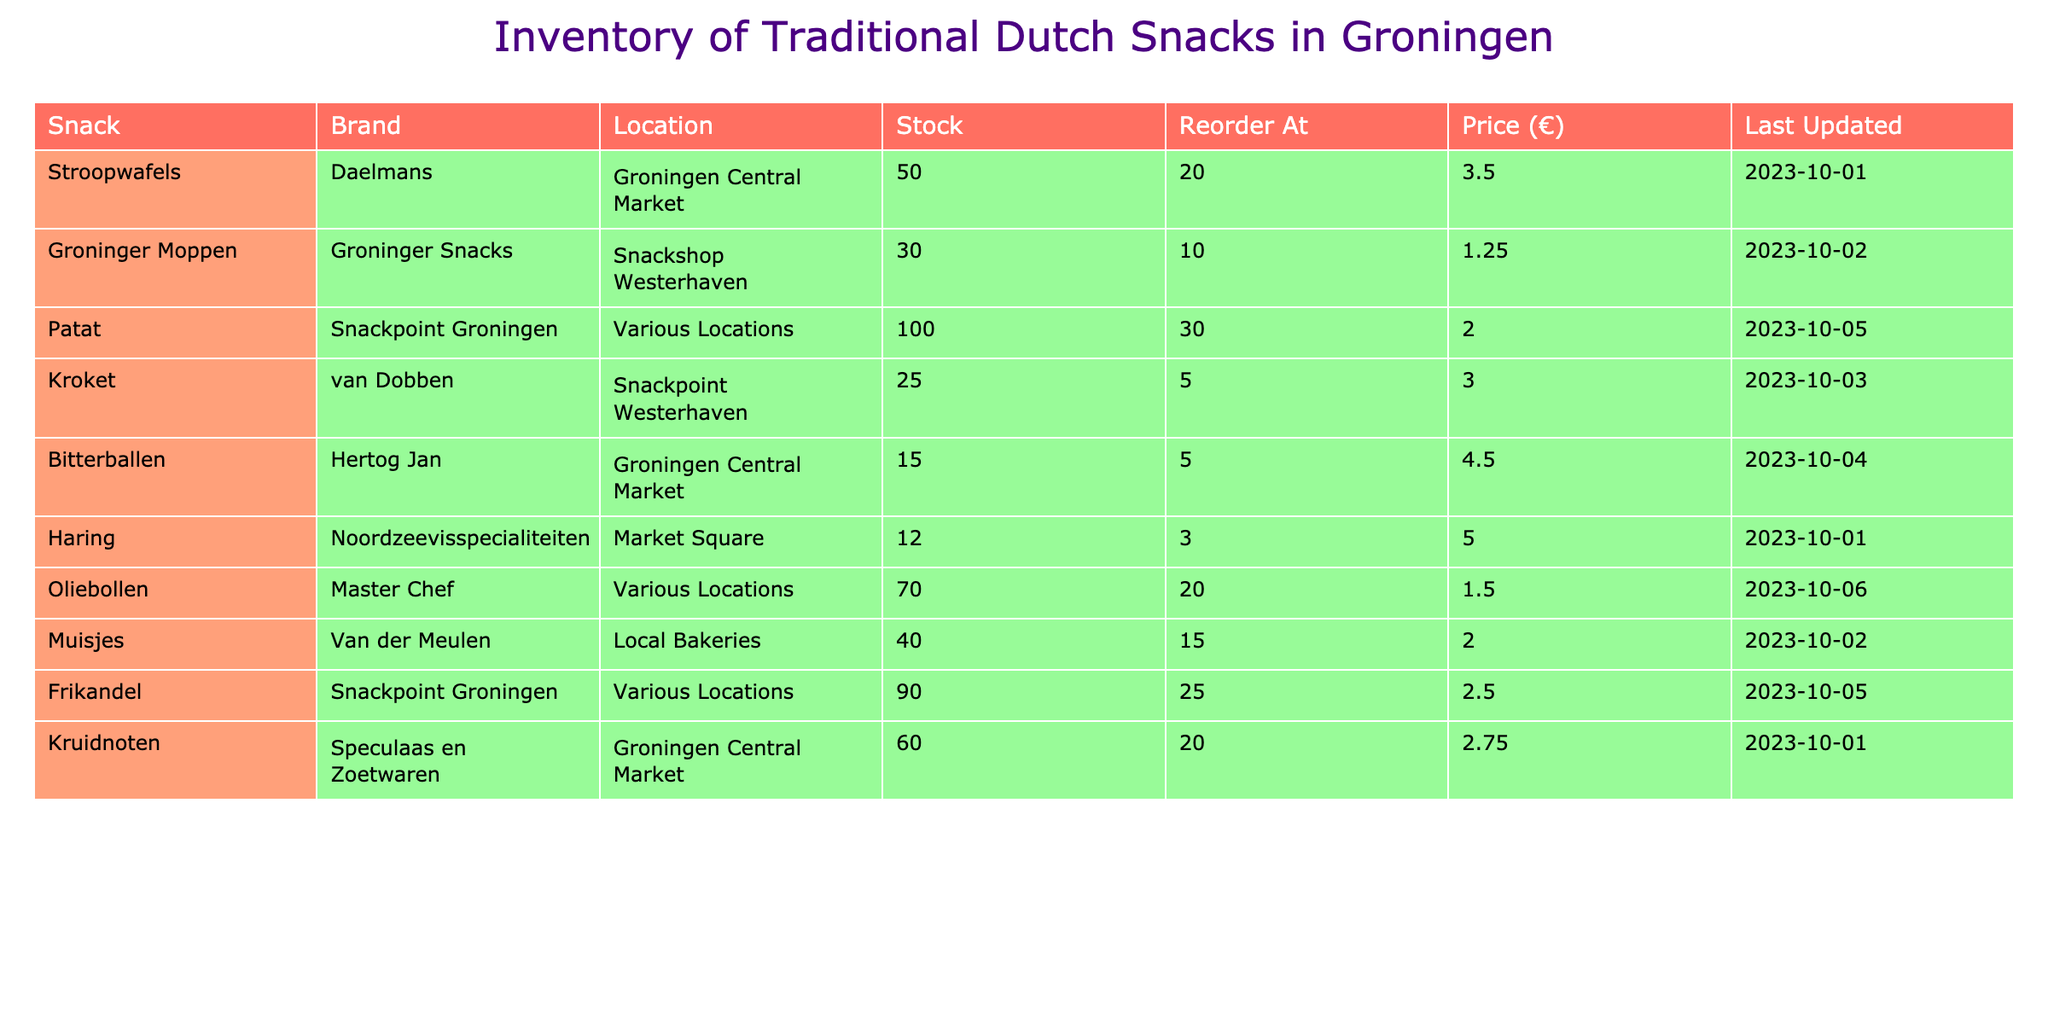What is the stock level of Stroopwafels? The table shows the stock level for each snack, and for Stroopwafels, it indicates 50 units.
Answer: 50 Which snack has the highest stock level? By examining the stock levels, Patat has the highest stock level at 100 units, compared to the others listed.
Answer: Patat Are there any snacks that have a stock level below their reorder threshold? By reviewing the table, the snacks Bitterballen (15), Haring (12), and Kroket (25) are all below their reorder thresholds (5, 3, and 5 respectively).
Answer: Yes What is the total stock of all snacks listed? Adding all the stock levels: 50 (Stroopwafels) + 30 (Groninger Moppen) + 100 (Patat) + 25 (Kroket) + 15 (Bitterballen) + 12 (Haring) + 70 (Oliebollen) + 40 (Muisjes) + 90 (Frikandel) + 60 (Kruidnoten) equals 452.
Answer: 452 Which snack has the most recently updated stock level? The last updated date for each snack reveals that Oliebollen was last updated on 2023-10-06, which is the most recent date.
Answer: Oliebollen Is the price per unit of Kroket higher than the average price of all snacks? First, calculate the average price: (3.50 + 1.25 + 2.00 + 3.00 + 4.50 + 5.00 + 1.50 + 2.00 + 2.50 + 2.75) = 24.00 and then divide by 10 for the average price, which is 2.40. Since Kroket's price is 3.00, it is higher than the average.
Answer: Yes How many snacks have a stock level of 20 or less? Looking through the stock levels, three snacks meet this criterion: Bitterballen (15), Haring (12), and Kroket (25) is the only one above. So, the total is two.
Answer: 3 What is the median price of the snacks? First, arrange the prices in order: 1.25, 1.50, 2.00, 2.00, 2.50, 2.75, 3.00, 3.50, 4.50, 5.00. Since there are an even number (10), the median is the average of the two middle numbers (2.50 and 2.75), which is (2.50 + 2.75)/2 = 2.625.
Answer: 2.625 Which snack is located at the Market Square? The table indicates that Haring is the snack located at the Market Square.
Answer: Haring 